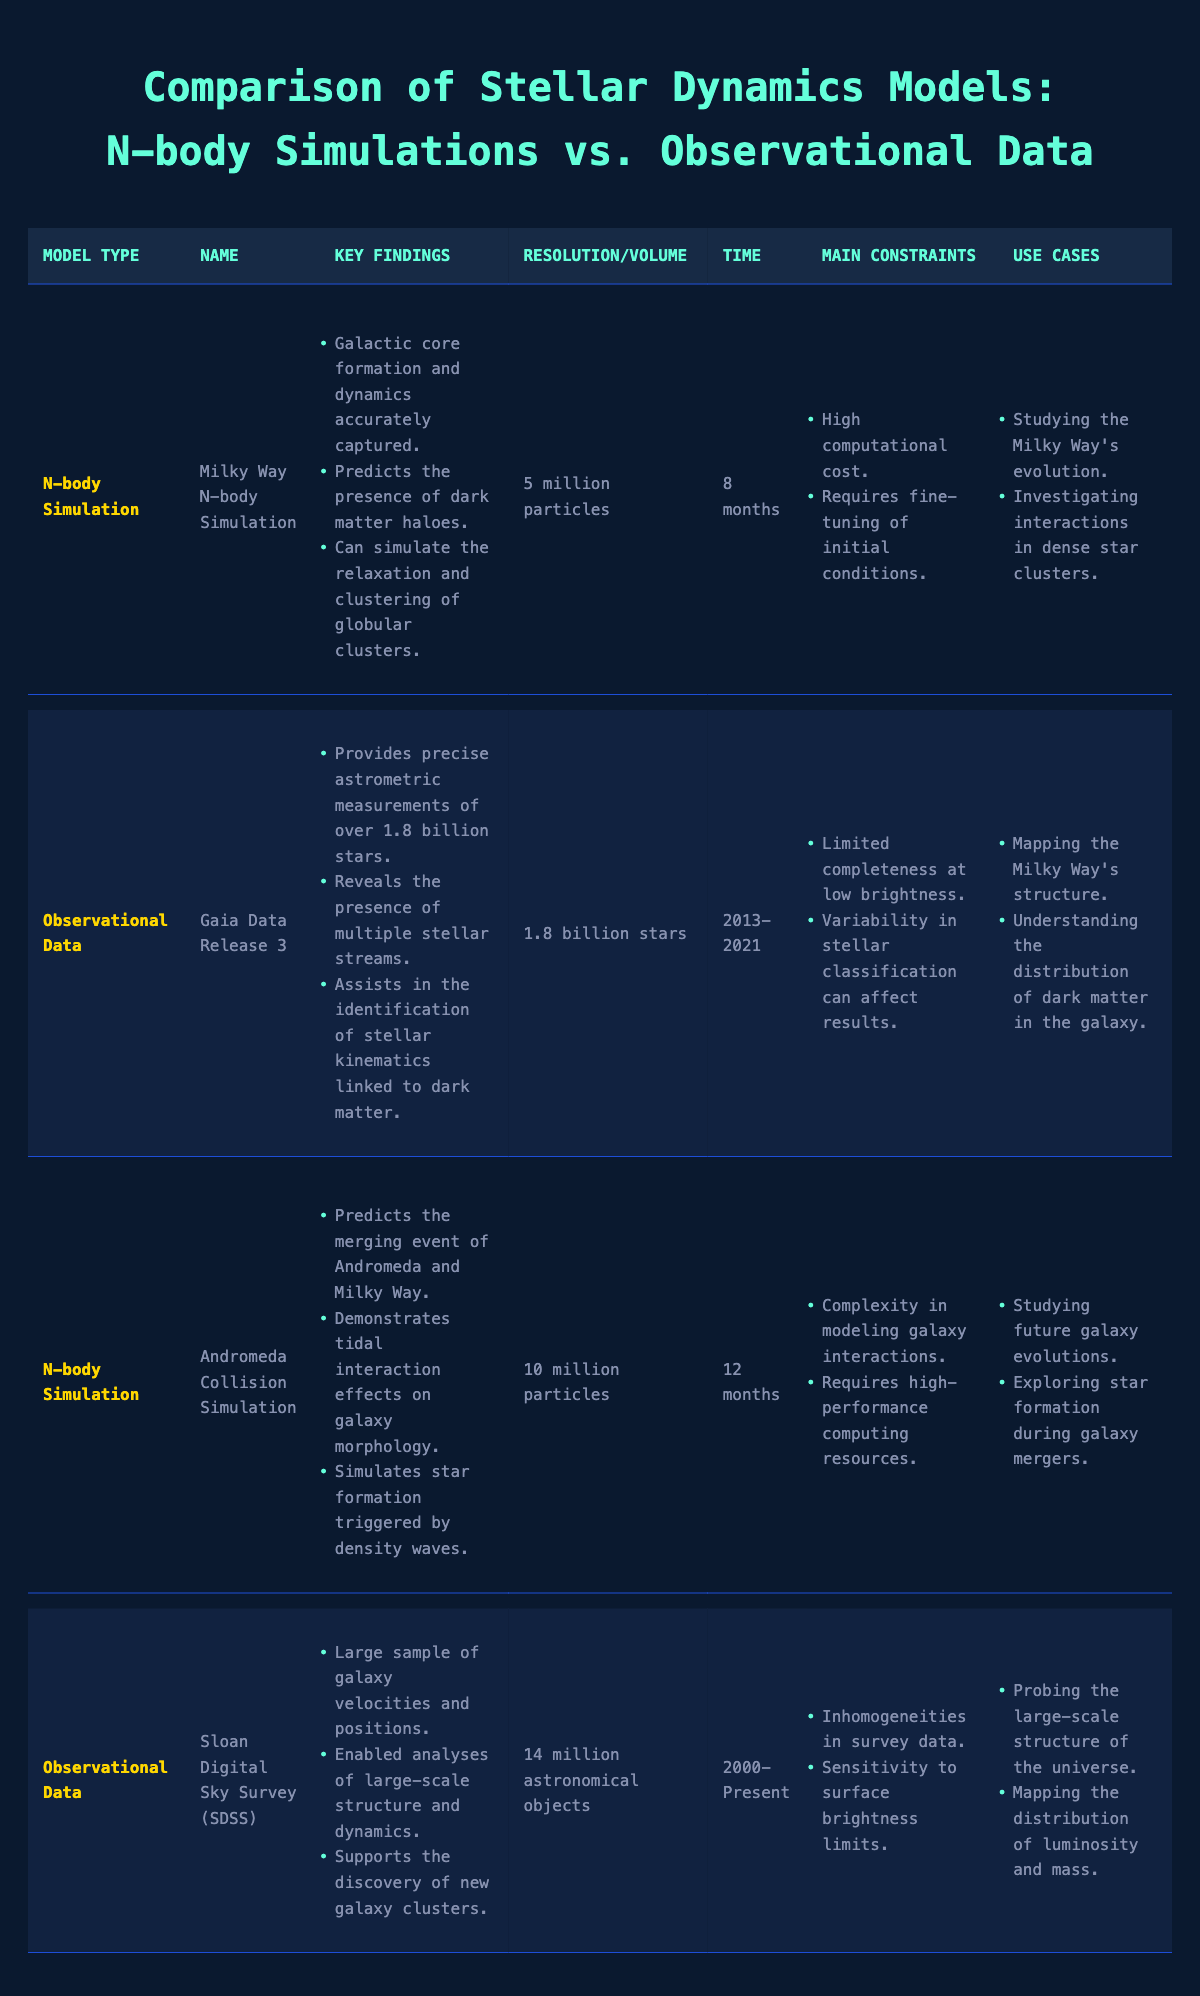What is the resolution of the Milky Way N-body Simulation? The table provides the resolution for each simulation. For the Milky Way N-body Simulation, it states "5 million particles."
Answer: 5 million particles Which observational dataset provides data on over 1.8 billion stars? The table shows that the Gaia Data Release 3 dataset is specifically mentioned to have precise measurements for over 1.8 billion stars.
Answer: Gaia Data Release 3 What is the run time of the Andromeda Collision Simulation? Looking at the table entry for the Andromeda Collision Simulation, the run time is specified as "12 months."
Answer: 12 months Did the Sloan Digital Sky Survey (SDSS) enable the discovery of new galaxy clusters? The key findings for the Sloan Digital Sky Survey (SDSS) include a bullet point stating that it "supports the discovery of new galaxy clusters," indicating that the answer is yes.
Answer: Yes What are the main constraints faced by N-body simulations according to the table? The table shows that for both N-body simulations, the main constraints listed include "high computational cost" and the "requirement for fine-tuning of initial conditions." This sums up the constraints faced by N-body simulations.
Answer: High computational cost; Requires fine-tuning of initial conditions Which model predicts the merging event of Andromeda and the Milky Way? The table mentions the Andromeda Collision Simulation under N-body simulations, specifically stating it predicts the merging event between Andromeda and the Milky Way.
Answer: Andromeda Collision Simulation How many astronomical objects are included in the Sloan Digital Sky Survey (SDSS)? The data in the table specifically lists the Sloan Digital Sky Survey (SDSS) as having "14 million astronomical objects."
Answer: 14 million astronomical objects What is the observation time span for the Gaia Data Release 3? The observation time span for the Gaia Data Release 3 is given as "2013-2021" in the table, providing a clear time frame for the data.
Answer: 2013-2021 Can the Milky Way N-body Simulation assist in investigating interactions in dense star clusters? The use cases for the Milky Way N-body Simulation include "investigating interactions in dense star clusters," which confirms that it can assist in this area.
Answer: Yes What is the average resolution of the N-body simulations listed in the table? The table shows two N-body simulations: Milky Way has a resolution of 5 million particles and Andromeda Collision has 10 million particles. The average is calculated as (5 + 10) / 2 = 7.5 million particles.
Answer: 7.5 million particles What model type has the highest data volume listed in the comparisons? Comparing the data volumes listed in the table, the Gaia Data Release 3 has a data volume of "1.8 billion stars," while the other models have smaller volumes. Thus, Gaia has the highest volume.
Answer: Observational Data (Gaia Data Release 3) 